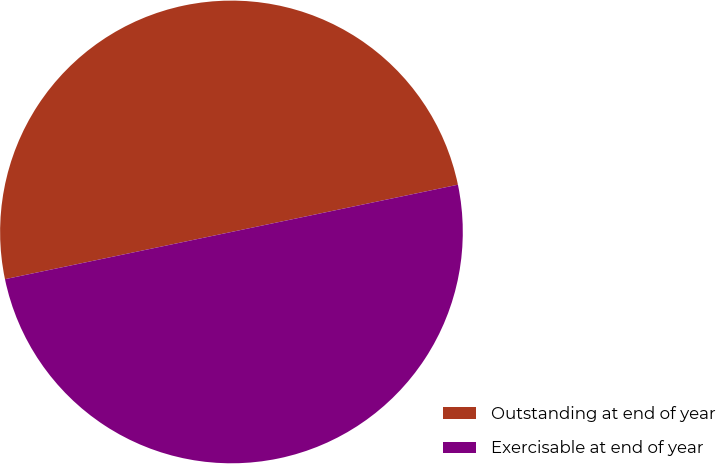Convert chart. <chart><loc_0><loc_0><loc_500><loc_500><pie_chart><fcel>Outstanding at end of year<fcel>Exercisable at end of year<nl><fcel>50.0%<fcel>50.0%<nl></chart> 